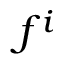<formula> <loc_0><loc_0><loc_500><loc_500>f ^ { i }</formula> 